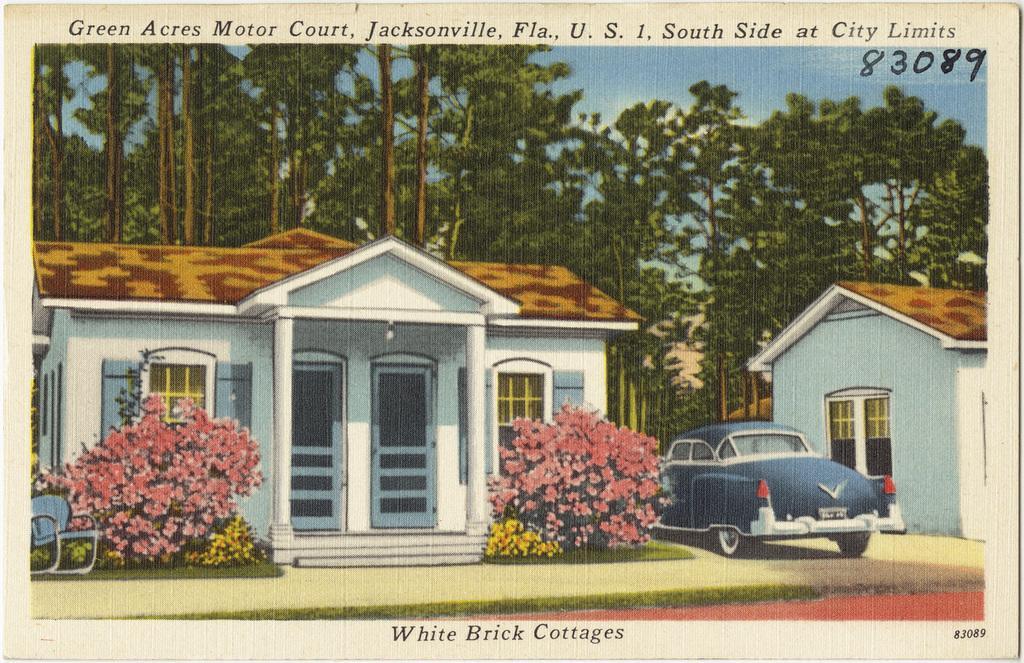Can you describe this image briefly? This image is a photograph. In this photo there are sheds and a car. At the bottom we can see bushes and there are flowers. In the background there are trees and sky. At the top and bottom we can see text. 